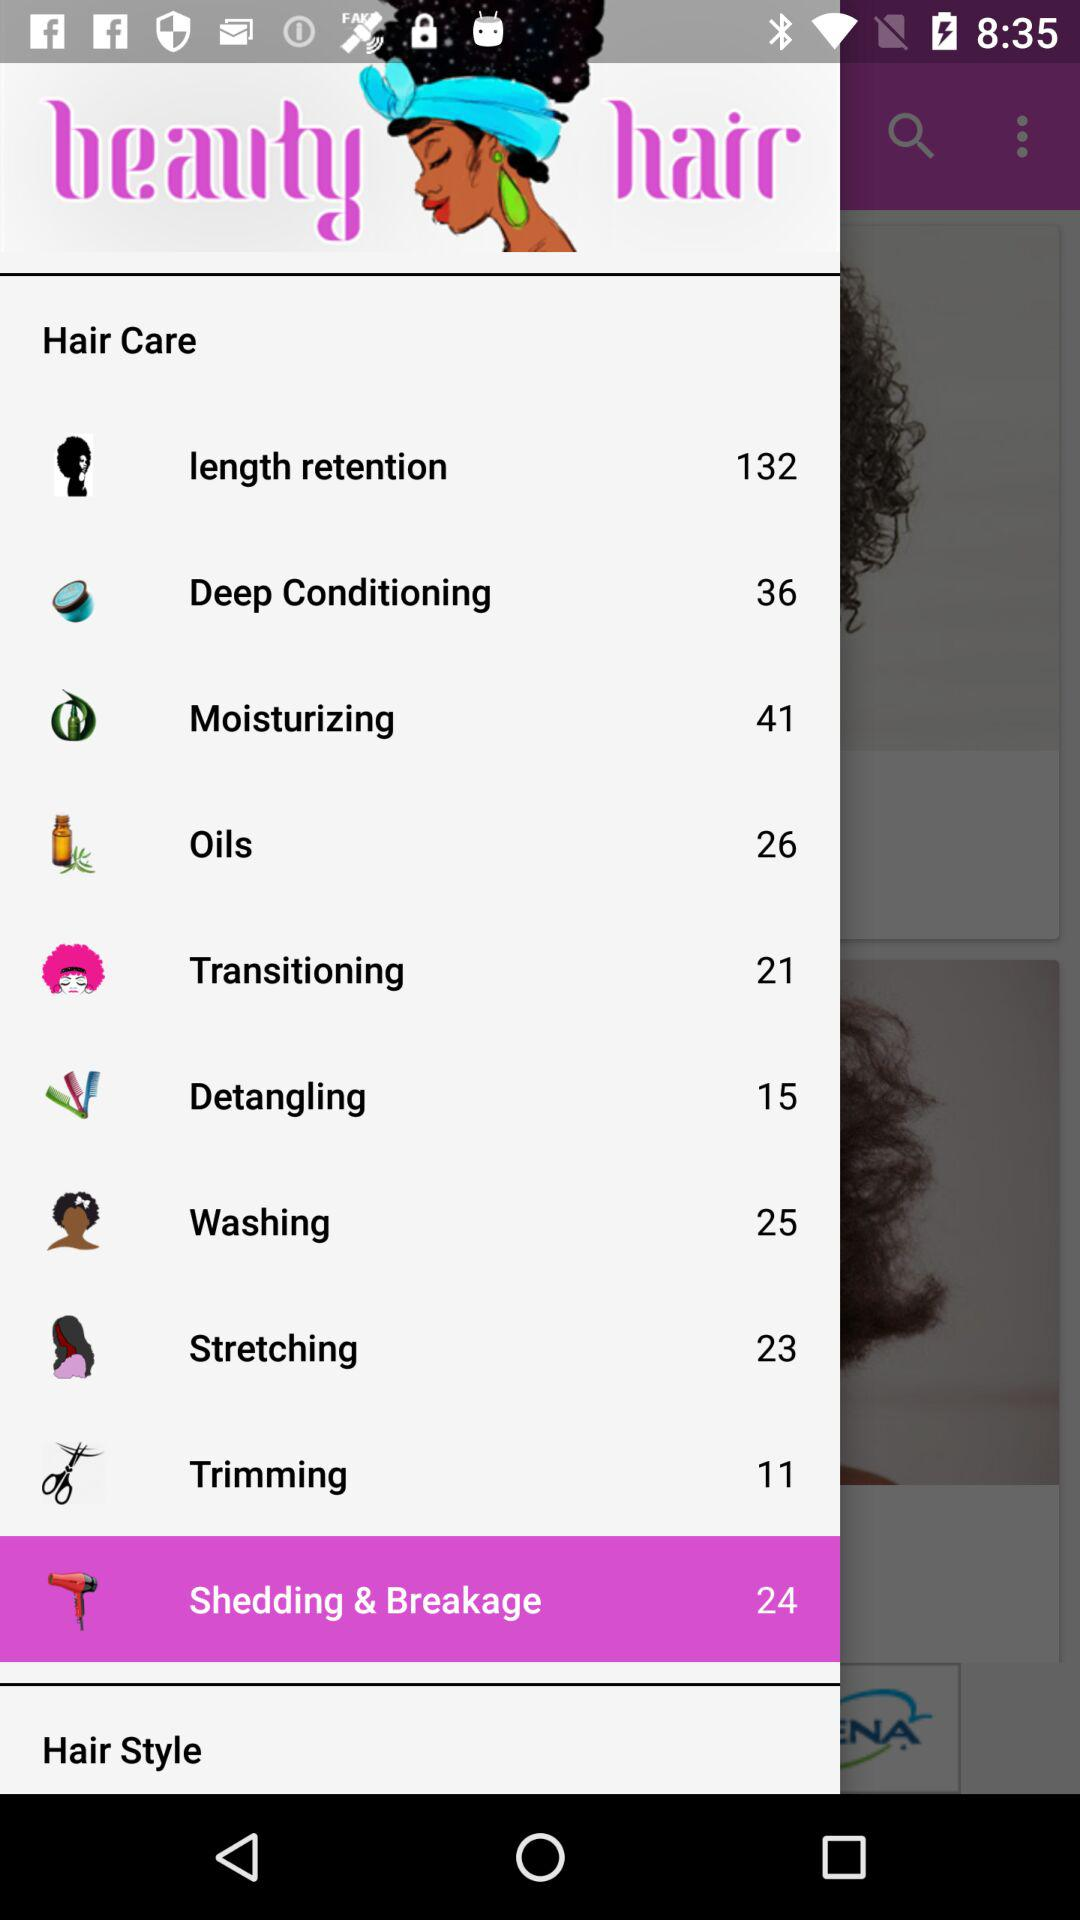What is the count of items in "Moisturizing"? The count of items in "Moisturizing" is 41. 